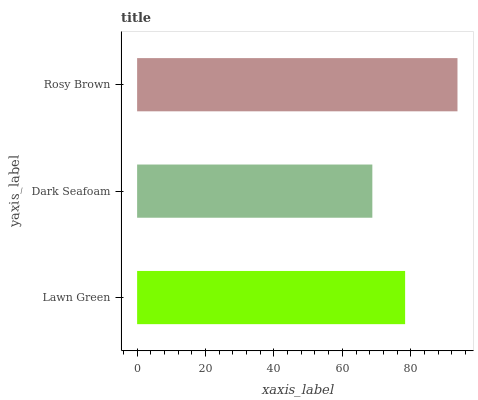Is Dark Seafoam the minimum?
Answer yes or no. Yes. Is Rosy Brown the maximum?
Answer yes or no. Yes. Is Rosy Brown the minimum?
Answer yes or no. No. Is Dark Seafoam the maximum?
Answer yes or no. No. Is Rosy Brown greater than Dark Seafoam?
Answer yes or no. Yes. Is Dark Seafoam less than Rosy Brown?
Answer yes or no. Yes. Is Dark Seafoam greater than Rosy Brown?
Answer yes or no. No. Is Rosy Brown less than Dark Seafoam?
Answer yes or no. No. Is Lawn Green the high median?
Answer yes or no. Yes. Is Lawn Green the low median?
Answer yes or no. Yes. Is Dark Seafoam the high median?
Answer yes or no. No. Is Dark Seafoam the low median?
Answer yes or no. No. 